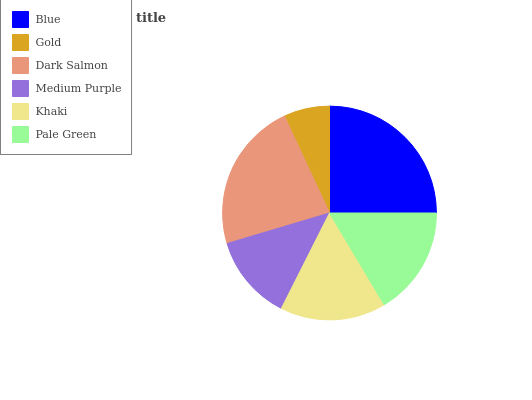Is Gold the minimum?
Answer yes or no. Yes. Is Blue the maximum?
Answer yes or no. Yes. Is Dark Salmon the minimum?
Answer yes or no. No. Is Dark Salmon the maximum?
Answer yes or no. No. Is Dark Salmon greater than Gold?
Answer yes or no. Yes. Is Gold less than Dark Salmon?
Answer yes or no. Yes. Is Gold greater than Dark Salmon?
Answer yes or no. No. Is Dark Salmon less than Gold?
Answer yes or no. No. Is Pale Green the high median?
Answer yes or no. Yes. Is Khaki the low median?
Answer yes or no. Yes. Is Khaki the high median?
Answer yes or no. No. Is Dark Salmon the low median?
Answer yes or no. No. 